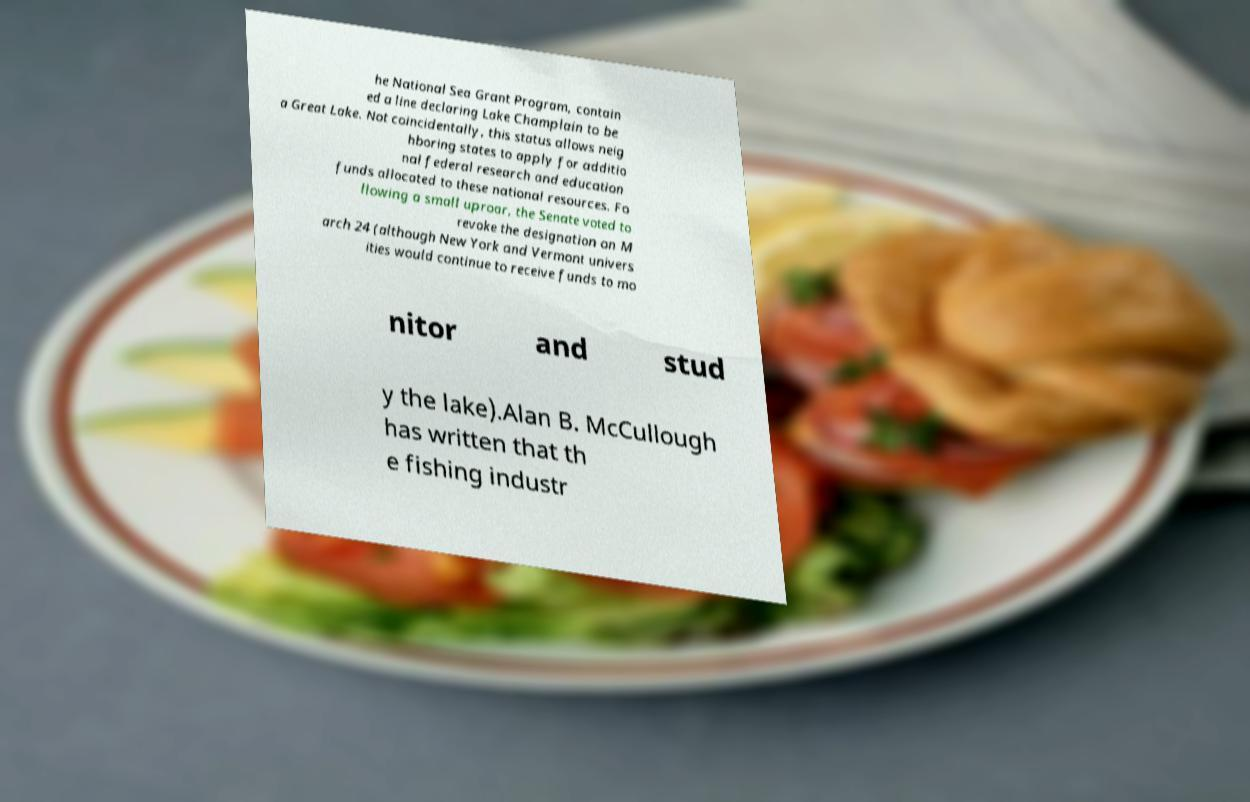Could you extract and type out the text from this image? he National Sea Grant Program, contain ed a line declaring Lake Champlain to be a Great Lake. Not coincidentally, this status allows neig hboring states to apply for additio nal federal research and education funds allocated to these national resources. Fo llowing a small uproar, the Senate voted to revoke the designation on M arch 24 (although New York and Vermont univers ities would continue to receive funds to mo nitor and stud y the lake).Alan B. McCullough has written that th e fishing industr 